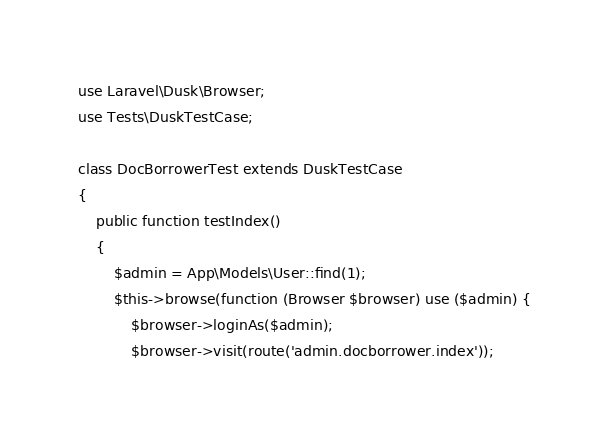Convert code to text. <code><loc_0><loc_0><loc_500><loc_500><_PHP_>use Laravel\Dusk\Browser;
use Tests\DuskTestCase;

class DocBorrowerTest extends DuskTestCase
{
    public function testIndex()
    {
        $admin = App\Models\User::find(1);
        $this->browse(function (Browser $browser) use ($admin) {
            $browser->loginAs($admin);
            $browser->visit(route('admin.docborrower.index'));</code> 